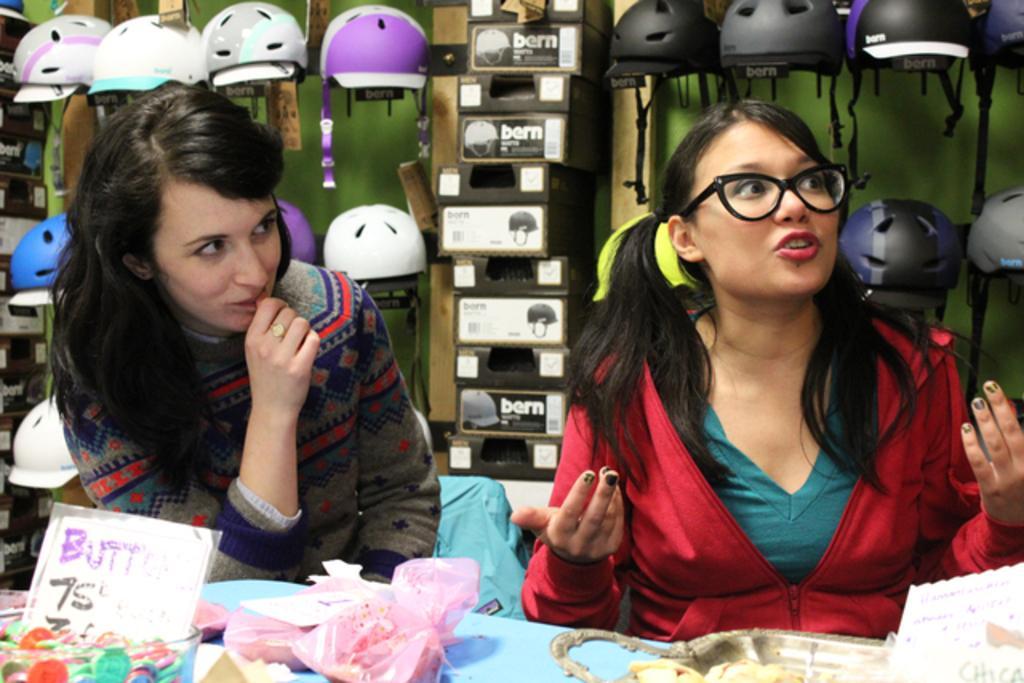Can you describe this image briefly? In this picture we can see two women where a woman wore a spectacle, jacket and in front of them we can see a tray, gift packets, bowl with a card, coins in it and in the background we can see helmets, boxes and some objects. 